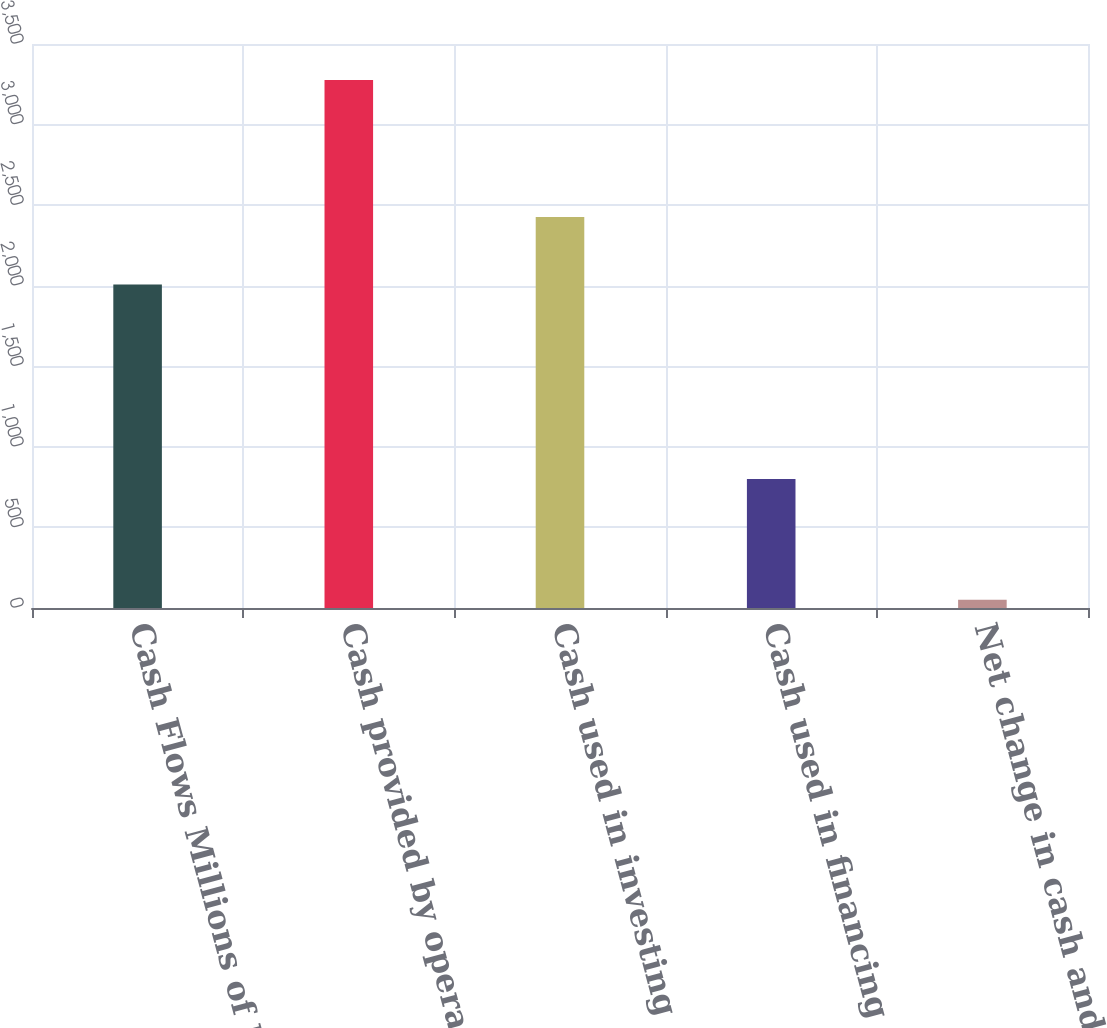<chart> <loc_0><loc_0><loc_500><loc_500><bar_chart><fcel>Cash Flows Millions of Dollars<fcel>Cash provided by operating<fcel>Cash used in investing<fcel>Cash used in financing<fcel>Net change in cash and cash<nl><fcel>2007<fcel>3277<fcel>2426<fcel>800<fcel>51<nl></chart> 